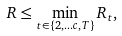Convert formula to latex. <formula><loc_0><loc_0><loc_500><loc_500>R \leq \min _ { t \in \{ 2 , \dots c , T \} } R _ { t } , \\</formula> 